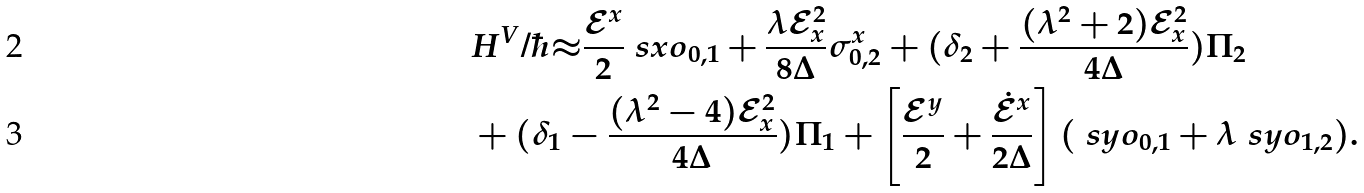<formula> <loc_0><loc_0><loc_500><loc_500>& H ^ { V } / \hbar { \approx } \frac { \mathcal { E } ^ { x } } { 2 } \ s x o _ { 0 , 1 } + \frac { \lambda \mathcal { E } _ { x } ^ { 2 } } { 8 \Delta } \sigma _ { 0 , 2 } ^ { x } + ( \delta _ { 2 } + \frac { ( \lambda ^ { 2 } + 2 ) \mathcal { E } _ { x } ^ { 2 } } { 4 \Delta } ) \Pi _ { 2 } \\ & + ( \delta _ { 1 } - \frac { ( \lambda ^ { 2 } - 4 ) \mathcal { E } _ { x } ^ { 2 } } { 4 \Delta } ) \Pi _ { 1 } + \left [ \frac { \mathcal { E } ^ { y } } { 2 } + \frac { \mathcal { \dot { E } } ^ { x } } { 2 \Delta } \right ] ( \ s y o _ { 0 , 1 } + \lambda \ s y o _ { 1 , 2 } ) .</formula> 